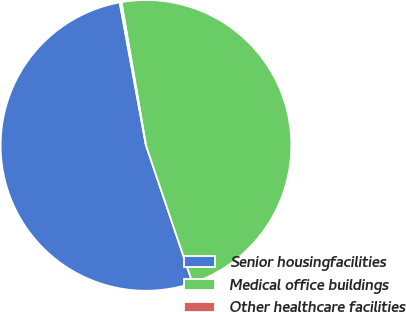<chart> <loc_0><loc_0><loc_500><loc_500><pie_chart><fcel>Senior housingfacilities<fcel>Medical office buildings<fcel>Other healthcare facilities<nl><fcel>52.29%<fcel>47.51%<fcel>0.2%<nl></chart> 